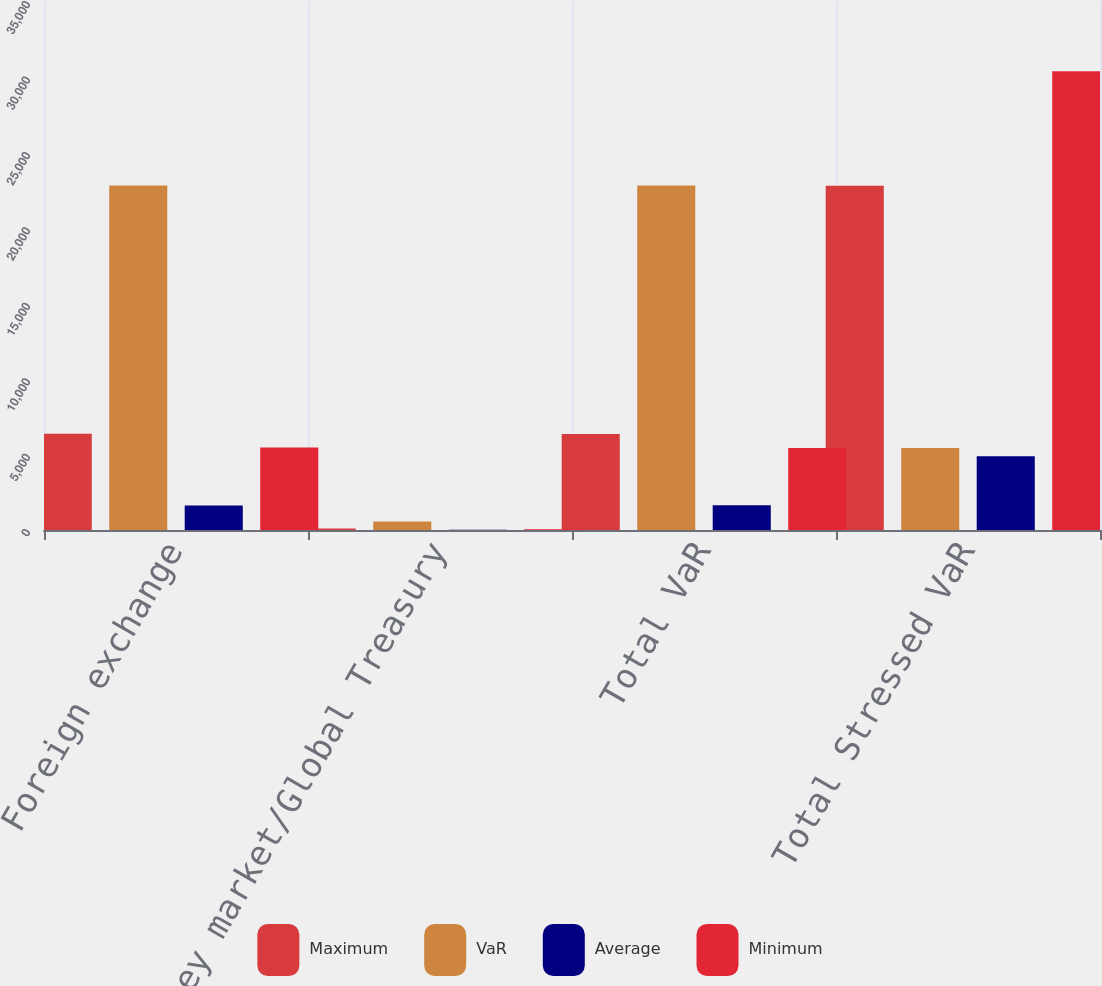Convert chart to OTSL. <chart><loc_0><loc_0><loc_500><loc_500><stacked_bar_chart><ecel><fcel>Foreign exchange<fcel>Money market/Global Treasury<fcel>Total VaR<fcel>Total Stressed VaR<nl><fcel>Maximum<fcel>6386<fcel>97<fcel>6361<fcel>22815<nl><fcel>VaR<fcel>22835<fcel>559<fcel>22834<fcel>5441<nl><fcel>Average<fcel>1626<fcel>24<fcel>1641<fcel>4889<nl><fcel>Minimum<fcel>5463<fcel>58<fcel>5441<fcel>30403<nl></chart> 